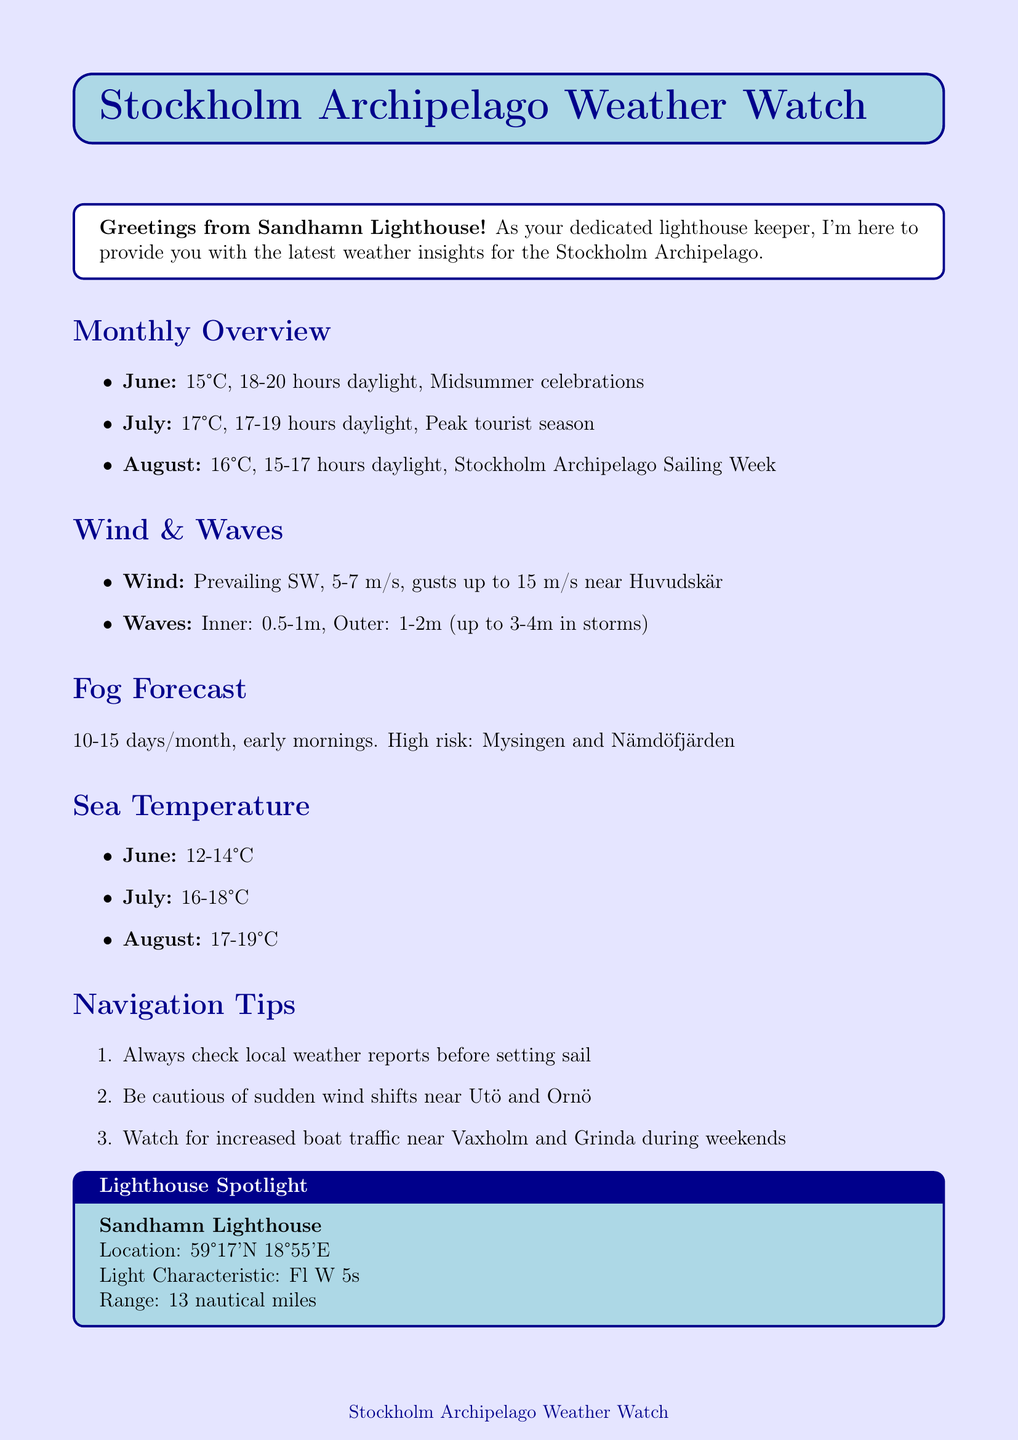What is the average temperature in July? The average temperature in July is specified in the monthly overview of the document.
Answer: 17°C How many daylight hours are there in August? The number of daylight hours in August is mentioned in the monthly overview.
Answer: 15-17 hours What are the peak hours for fog? The document states when fog is most likely to occur.
Answer: Early morning What is the wave height in the outer archipelago? The wave heights for different areas are detailed in the wave section of the document.
Answer: 1-2 meters How often does fog occur per month? The document provides the frequency of fog occurrence in the forecast section.
Answer: 10-15 days per month What is the characteristic of the Sandhamn Lighthouse? The lighthouse spotlight section describes its features.
Answer: Fl W 5s Why should sailors be cautious near Utö and Ornö? The navigation tips provide reasons related to wind shifts in these areas.
Answer: Sudden wind shifts What local wisdom is mentioned in the newsletter? The document includes a piece of local wisdom reflecting common sentiments about weather in the archipelago.
Answer: "If you don't like the weather, wait five minutes!" What is the average temperature range for the sea in June? The sea temperature section details the temperature range for each month.
Answer: 12-14°C 